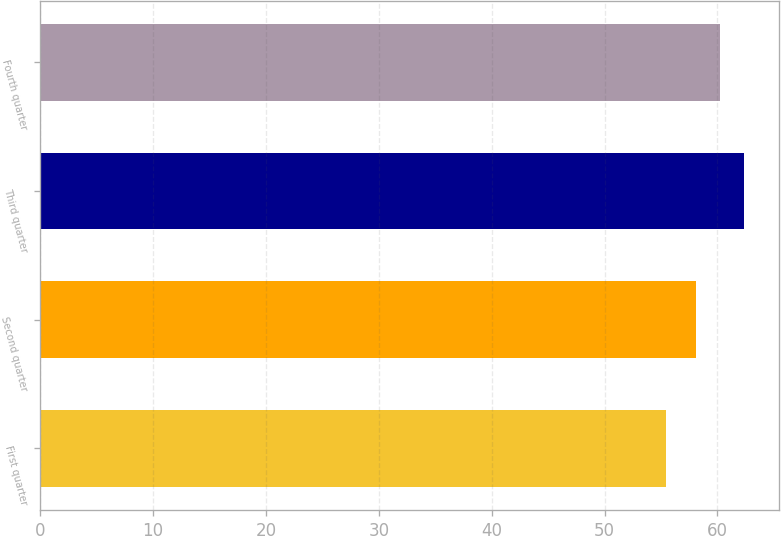Convert chart to OTSL. <chart><loc_0><loc_0><loc_500><loc_500><bar_chart><fcel>First quarter<fcel>Second quarter<fcel>Third quarter<fcel>Fourth quarter<nl><fcel>55.43<fcel>58.06<fcel>62.33<fcel>60.21<nl></chart> 